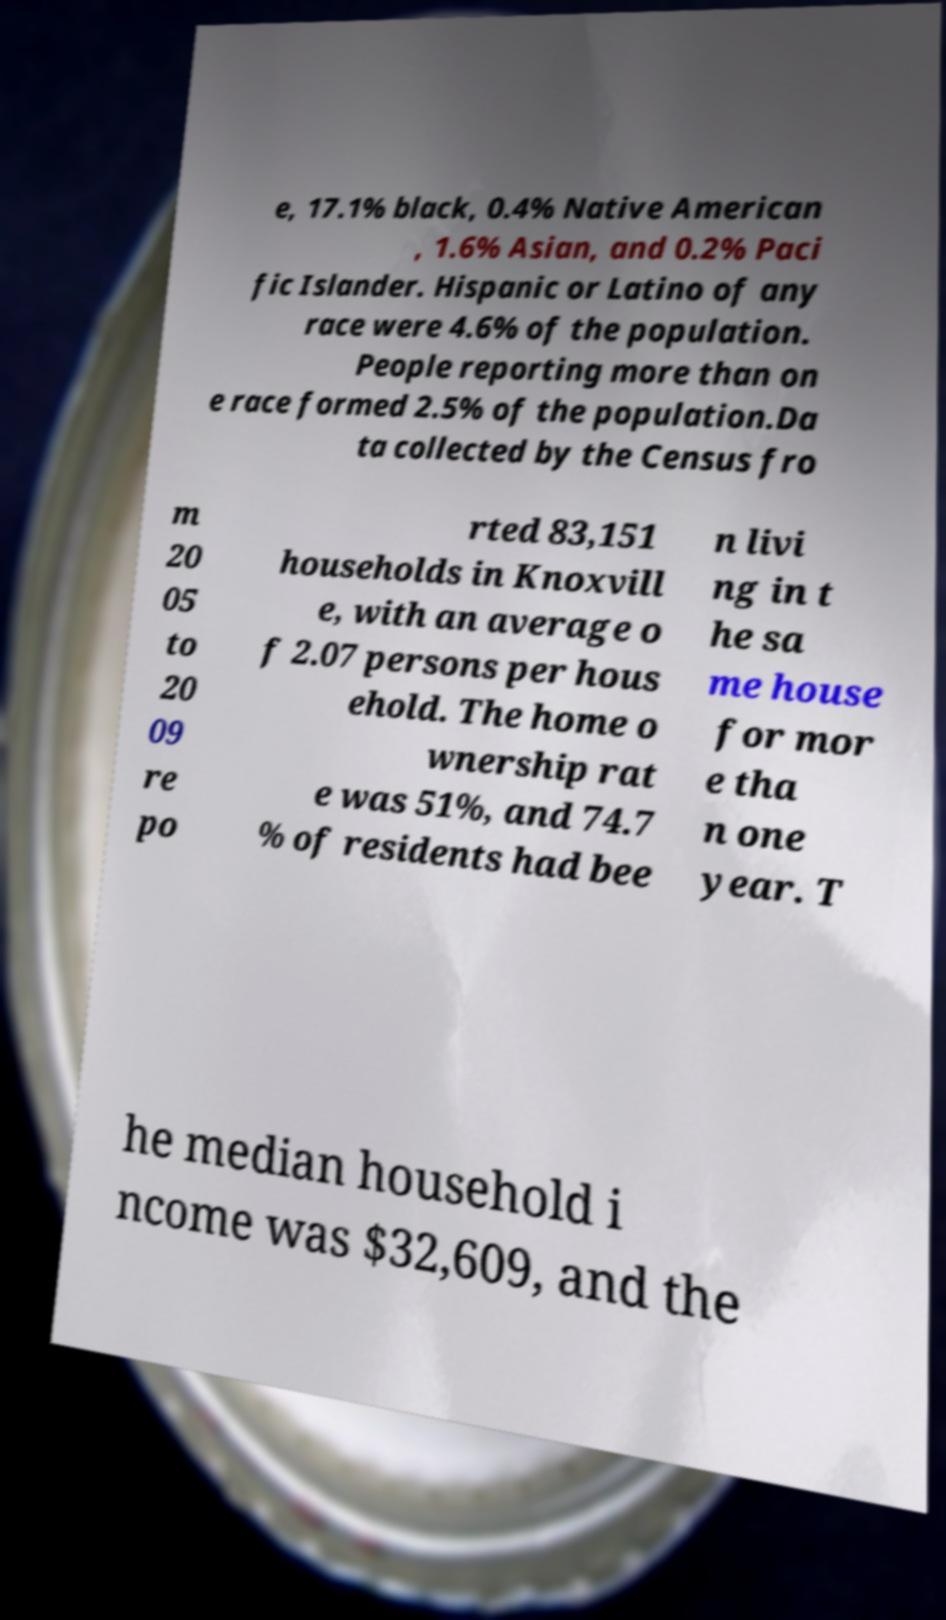There's text embedded in this image that I need extracted. Can you transcribe it verbatim? e, 17.1% black, 0.4% Native American , 1.6% Asian, and 0.2% Paci fic Islander. Hispanic or Latino of any race were 4.6% of the population. People reporting more than on e race formed 2.5% of the population.Da ta collected by the Census fro m 20 05 to 20 09 re po rted 83,151 households in Knoxvill e, with an average o f 2.07 persons per hous ehold. The home o wnership rat e was 51%, and 74.7 % of residents had bee n livi ng in t he sa me house for mor e tha n one year. T he median household i ncome was $32,609, and the 